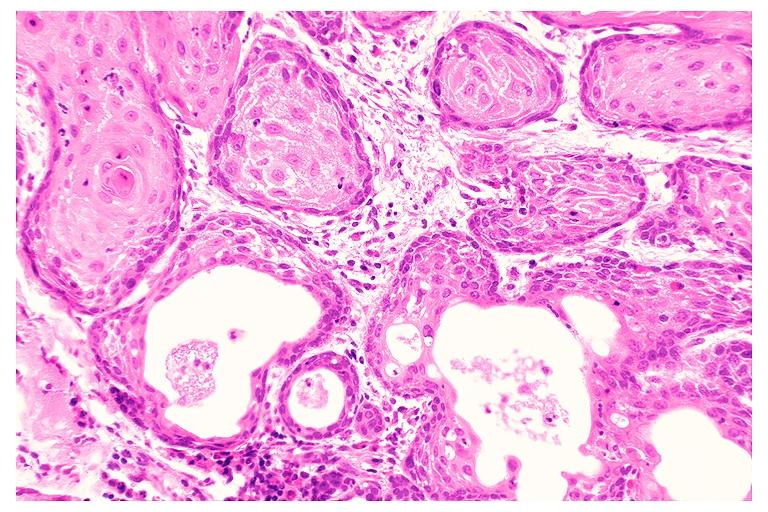where is this?
Answer the question using a single word or phrase. Oral 